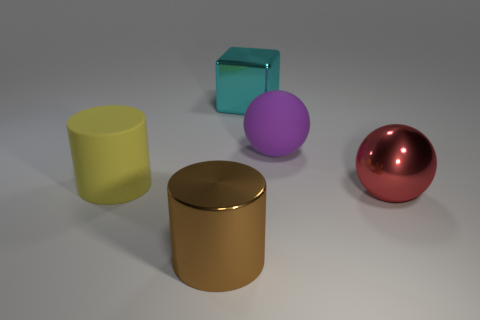What color is the matte ball that is the same size as the metal ball?
Your answer should be compact. Purple. Are the large ball that is in front of the purple matte object and the thing that is behind the large purple rubber object made of the same material?
Offer a terse response. Yes. There is a large purple sphere behind the brown metallic object; what material is it?
Keep it short and to the point. Rubber. What number of things are either matte things that are on the left side of the brown cylinder or objects to the left of the large purple thing?
Offer a terse response. 3. What material is the other object that is the same shape as the big brown thing?
Give a very brief answer. Rubber. Are there any green rubber cylinders that have the same size as the metal block?
Offer a very short reply. No. There is a big thing that is behind the metallic ball and in front of the purple rubber ball; what material is it?
Ensure brevity in your answer.  Rubber. What number of metallic things are either large cyan objects or gray balls?
Keep it short and to the point. 1. What is the shape of the cyan object that is made of the same material as the red thing?
Ensure brevity in your answer.  Cube. What number of shiny objects are in front of the big metallic ball and behind the yellow rubber object?
Keep it short and to the point. 0. 